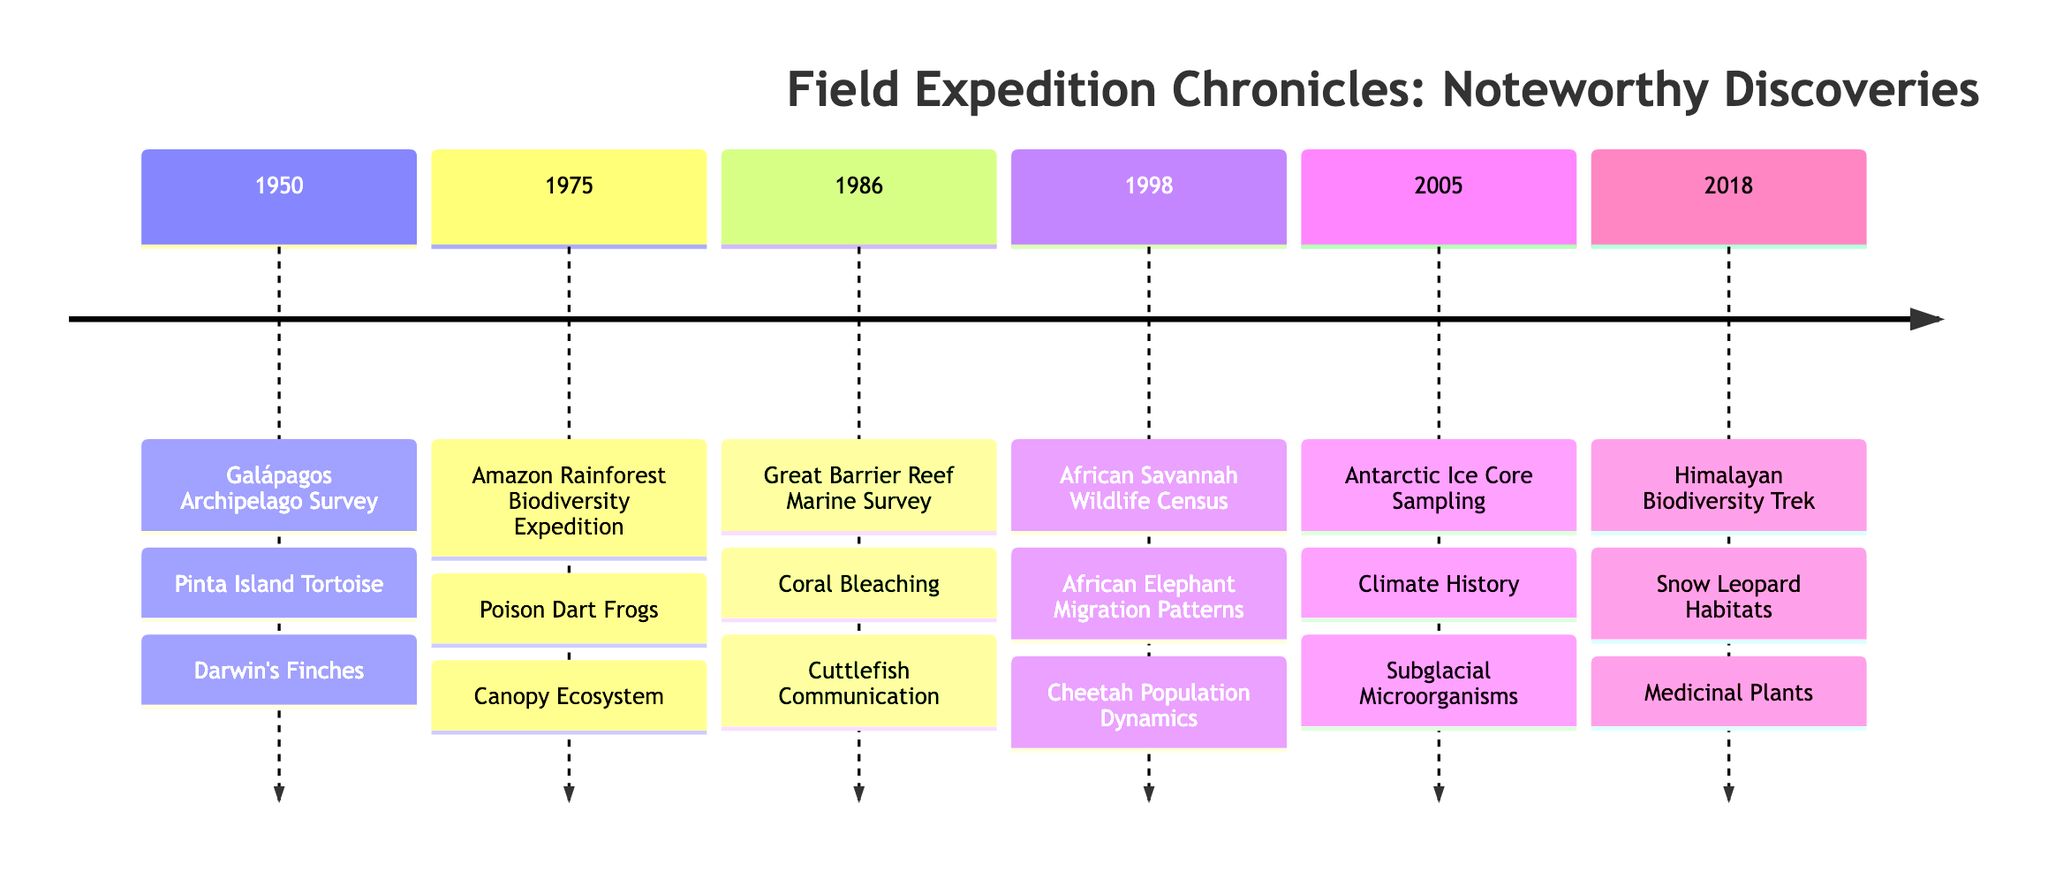What was the first discovery recorded in 1950? The timeline indicates that the first expedition in 1950 was the Galápagos Archipelago Survey, which included the Pinta Island Tortoise as its first documented discovery.
Answer: Pinta Island Tortoise How many expeditions took place in the 1980s? The timeline compiles expeditions by decade. Only one expedition, the Great Barrier Reef Marine Survey, occurred in the 1980s (1986).
Answer: 1 Which expedition documented climate history? The Antarctic Ice Core Sampling expedition in 2005 is noted for its discovery related to climate history through ice core analysis.
Answer: Antarctic Ice Core Sampling What year did the African Savannah Wildlife Census occur? On the timeline, the African Savannah Wildlife Census is documented for the year 1998, making that the answer.
Answer: 1998 Which survey is related to snow leopard habitats? The Himalaya Biodiversity Trek in 2018 focused on mapping the snow leopard habitats, making it the related survey.
Answer: Himalayan Biodiversity Trek What notable discovery about frogs was made in 1975? The Amazon Rainforest Biodiversity Expedition in 1975 identified three new species of poison dart frogs as a significant discovery.
Answer: Poison Dart Frogs How many discoveries were made during the 2005 expedition? In 2005, the Antarctic Ice Core Sampling expedition listed two discoveries: Climate History and Subglacial Microorganisms. Therefore, the answer is two.
Answer: 2 Which decade had the most discoveries documented on the timeline? By reviewing the discoveries listed under each expedition, the 2005 Antarctic Ice Core Sampling expedition recorded the most discoveries (two), matching the 1998 expedition. However, multiple instances suggest there's no single decade with more than two discoveries listed.
Answer: 2005 and 1998 What was a significant finding in the Great Barrier Reef Marine Survey? According to the timeline, the Great Barrier Reef Marine Survey in 1986 documented coral bleaching as a significant finding linked to climate change.
Answer: Coral Bleaching 